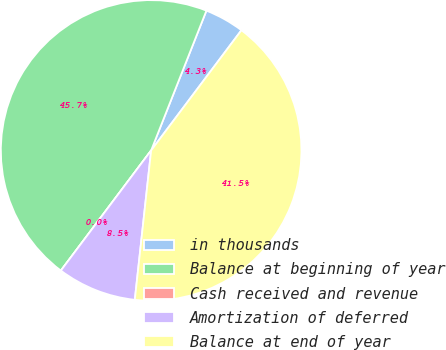Convert chart to OTSL. <chart><loc_0><loc_0><loc_500><loc_500><pie_chart><fcel>in thousands<fcel>Balance at beginning of year<fcel>Cash received and revenue<fcel>Amortization of deferred<fcel>Balance at end of year<nl><fcel>4.26%<fcel>45.74%<fcel>0.0%<fcel>8.52%<fcel>41.48%<nl></chart> 